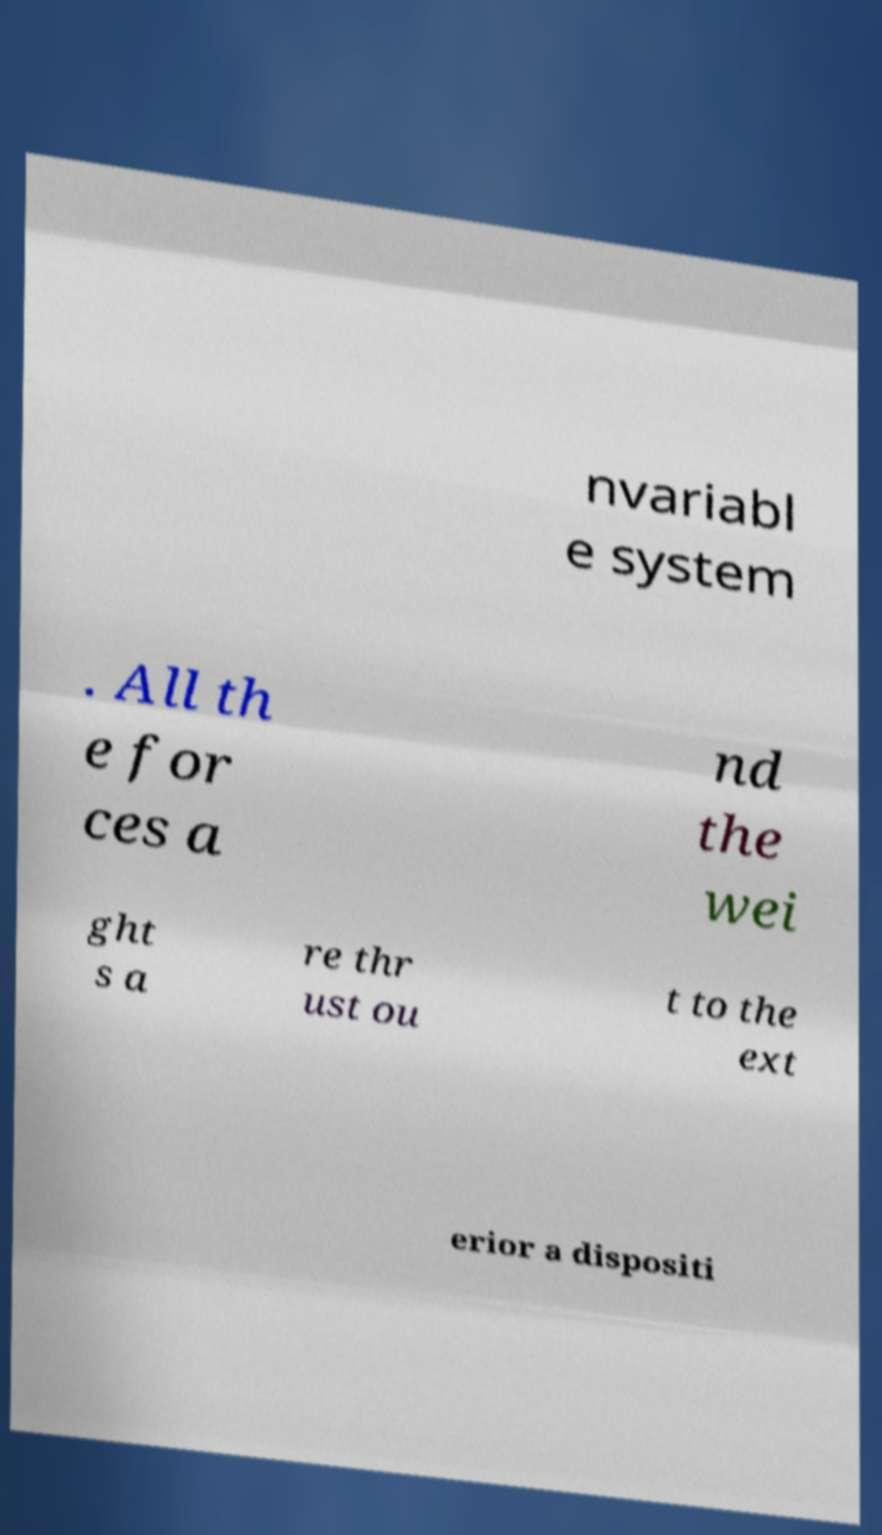Can you accurately transcribe the text from the provided image for me? nvariabl e system . All th e for ces a nd the wei ght s a re thr ust ou t to the ext erior a dispositi 